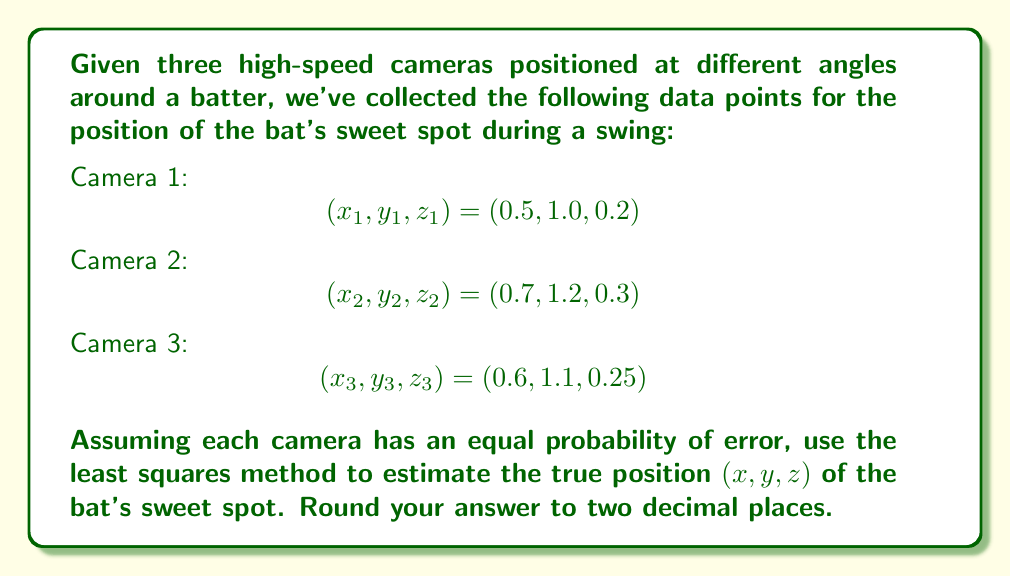Can you answer this question? To solve this inverse problem and reconstruct the batter's swing path, we'll use the least squares method:

1) The objective is to minimize the sum of squared differences between our estimate and each camera's measurement.

2) Let $(x, y, z)$ be our estimate. We want to minimize:

   $$S = (x-x_1)^2 + (y-y_1)^2 + (z-z_1)^2 + (x-x_2)^2 + (y-y_2)^2 + (z-z_2)^2 + (x-x_3)^2 + (y-y_3)^2 + (z-z_3)^2$$

3) To minimize S, we take partial derivatives with respect to x, y, and z and set them to zero:

   $$\frac{\partial S}{\partial x} = 2(x-x_1) + 2(x-x_2) + 2(x-x_3) = 0$$
   $$\frac{\partial S}{\partial y} = 2(y-y_1) + 2(y-y_2) + 2(y-y_3) = 0$$
   $$\frac{\partial S}{\partial z} = 2(z-z_1) + 2(z-z_2) + 2(z-z_3) = 0$$

4) Solving these equations:

   $$3x = x_1 + x_2 + x_3$$
   $$3y = y_1 + y_2 + y_3$$
   $$3z = z_1 + z_2 + z_3$$

5) Therefore, our best estimate is the average of the three measurements:

   $$x = \frac{x_1 + x_2 + x_3}{3} = \frac{0.5 + 0.7 + 0.6}{3} = 0.60$$
   $$y = \frac{y_1 + y_2 + y_3}{3} = \frac{1.0 + 1.2 + 1.1}{3} = 1.10$$
   $$z = \frac{z_1 + z_2 + z_3}{3} = \frac{0.2 + 0.3 + 0.25}{3} = 0.25$$

6) Rounding to two decimal places, our final estimate is (0.60, 1.10, 0.25).
Answer: (0.60, 1.10, 0.25) 